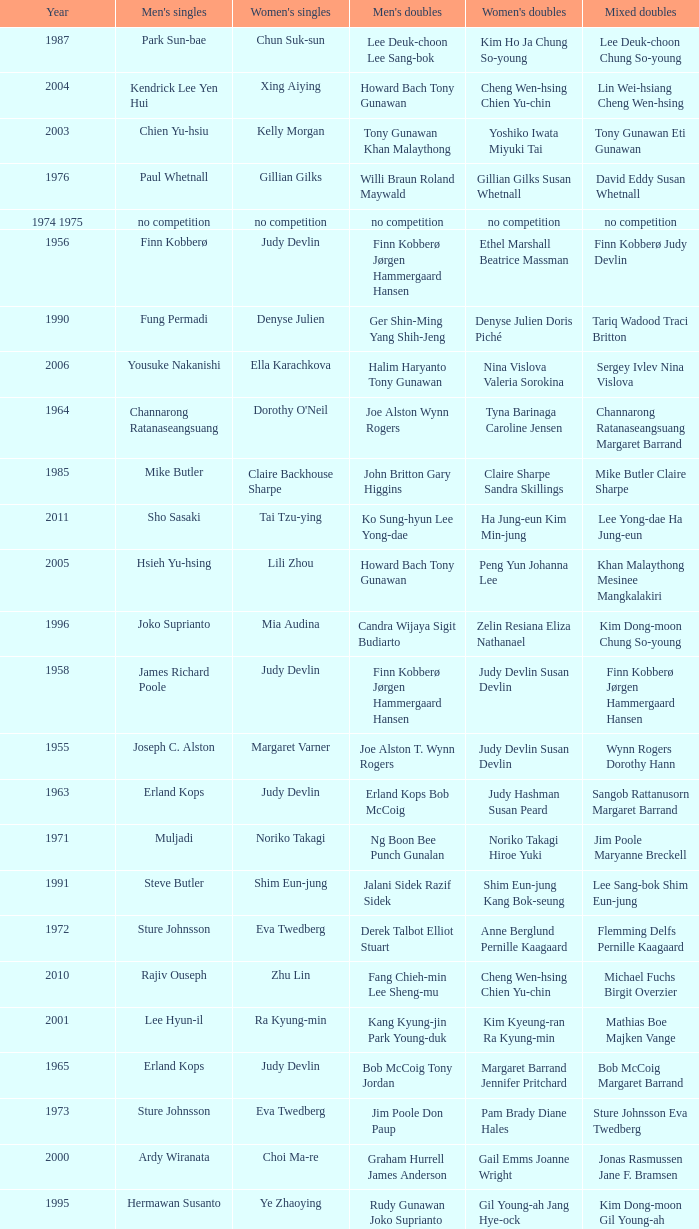Who was the women's singles champion in 1984? Luo Yun. 